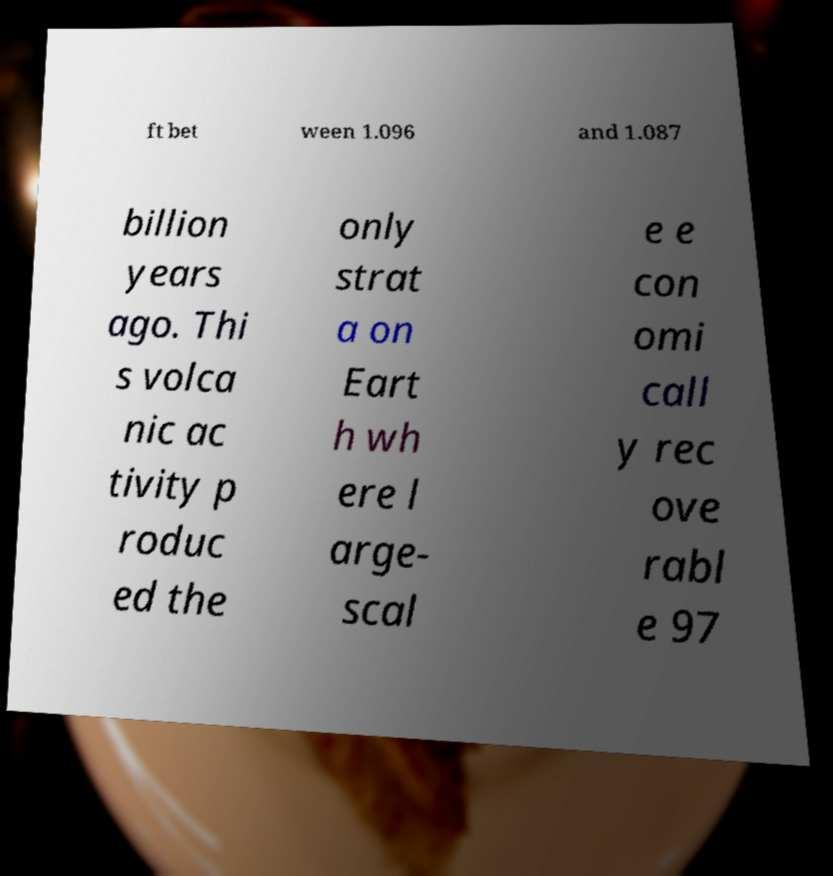Please read and relay the text visible in this image. What does it say? ft bet ween 1.096 and 1.087 billion years ago. Thi s volca nic ac tivity p roduc ed the only strat a on Eart h wh ere l arge- scal e e con omi call y rec ove rabl e 97 